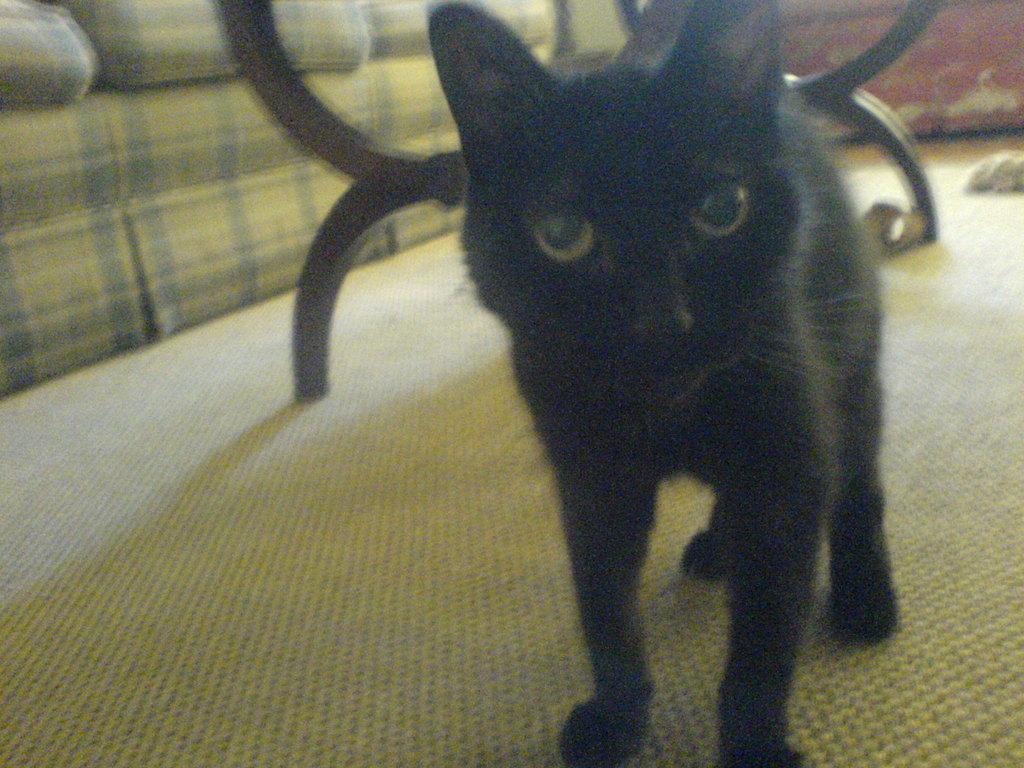Please provide a concise description of this image. In this image, we can see a black color cat standing on the carpet, at the left side there is a sofa. 